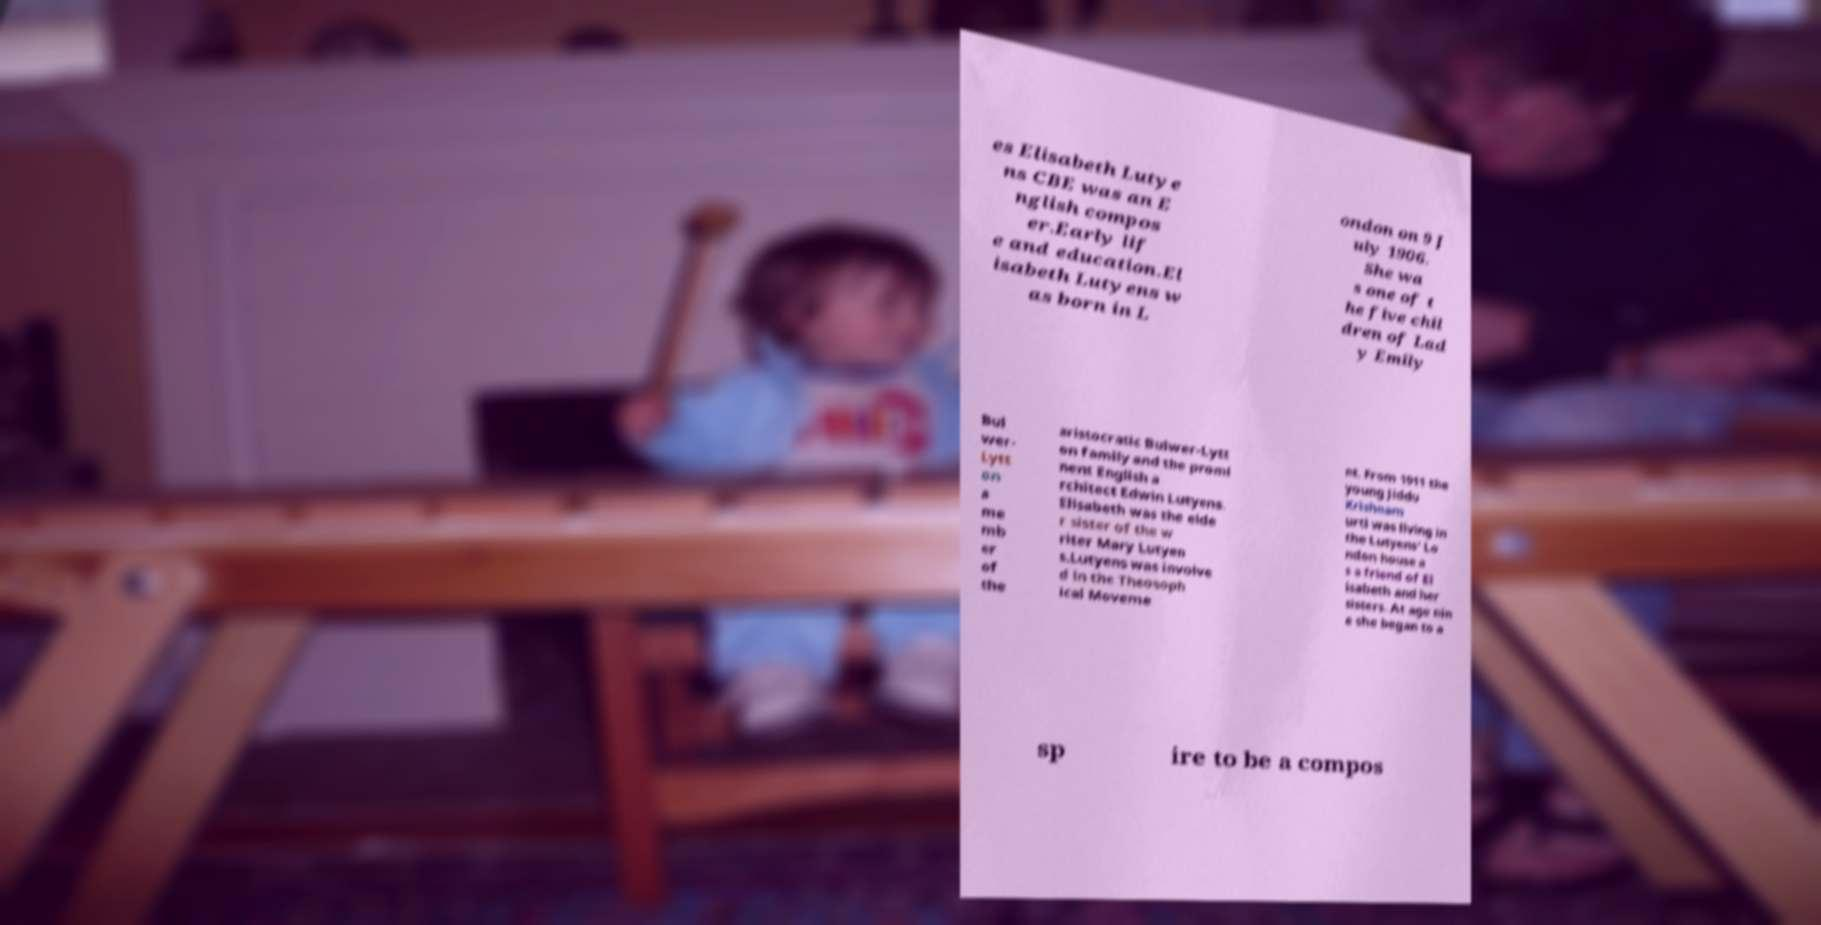Can you read and provide the text displayed in the image?This photo seems to have some interesting text. Can you extract and type it out for me? es Elisabeth Lutye ns CBE was an E nglish compos er.Early lif e and education.El isabeth Lutyens w as born in L ondon on 9 J uly 1906. She wa s one of t he five chil dren of Lad y Emily Bul wer- Lytt on a me mb er of the aristocratic Bulwer-Lytt on family and the promi nent English a rchitect Edwin Lutyens. Elisabeth was the elde r sister of the w riter Mary Lutyen s.Lutyens was involve d in the Theosoph ical Moveme nt. From 1911 the young Jiddu Krishnam urti was living in the Lutyens' Lo ndon house a s a friend of El isabeth and her sisters. At age nin e she began to a sp ire to be a compos 